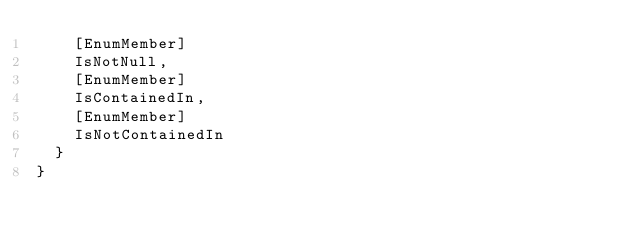Convert code to text. <code><loc_0><loc_0><loc_500><loc_500><_C#_>		[EnumMember]
		IsNotNull,
		[EnumMember]
		IsContainedIn,
		[EnumMember]
		IsNotContainedIn
	}
}</code> 